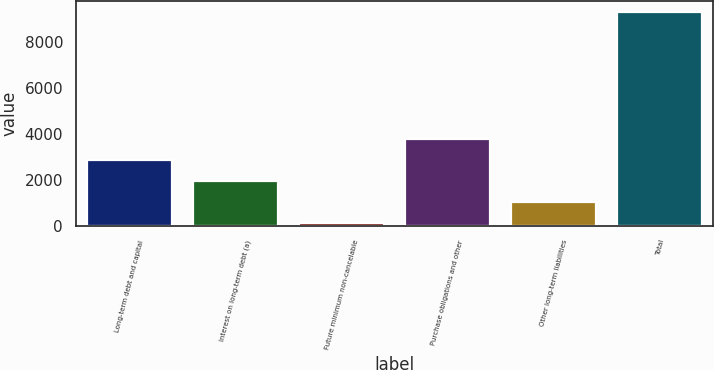Convert chart to OTSL. <chart><loc_0><loc_0><loc_500><loc_500><bar_chart><fcel>Long-term debt and capital<fcel>Interest on long-term debt (a)<fcel>Future minimum non-cancelable<fcel>Purchase obligations and other<fcel>Other long-term liabilities<fcel>Total<nl><fcel>2873<fcel>1954<fcel>116<fcel>3792<fcel>1035<fcel>9306<nl></chart> 